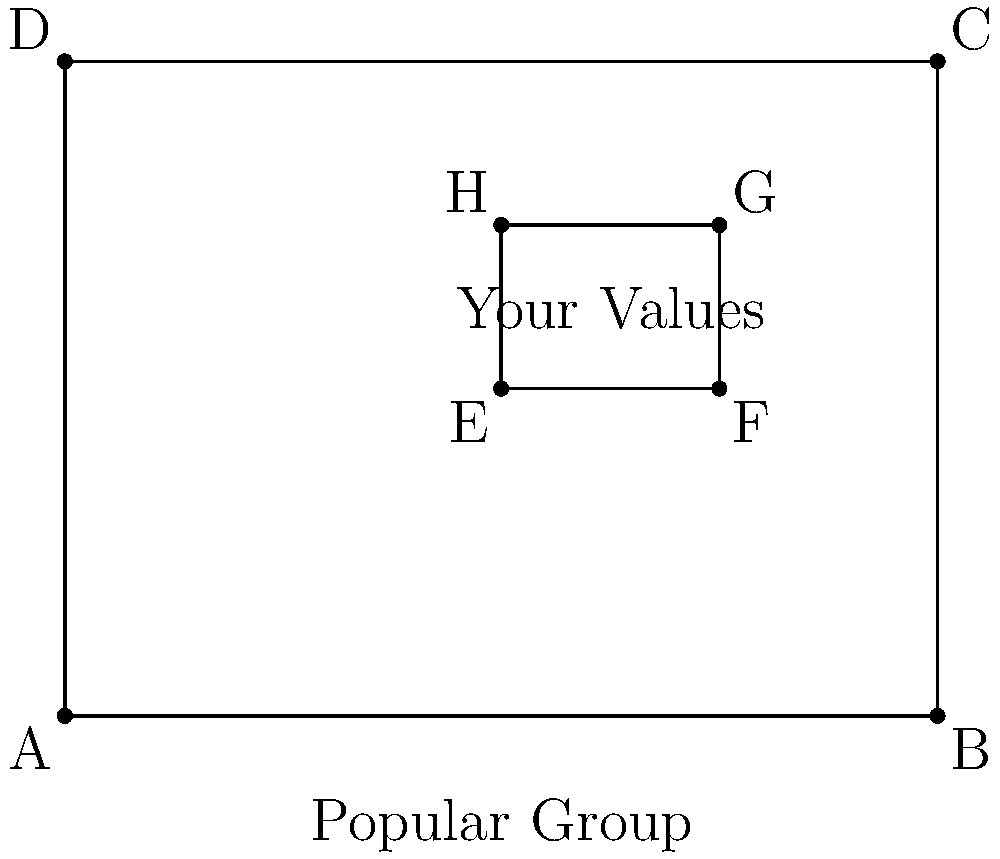In the diagram, rectangle ABCD represents the "Popular Group" at your high school, while rectangle EFGH represents "Your Values". If EFGH is congruent to a rectangle that is 25% of ABCD's area, what fraction of your values align with the popular group's values? Express your answer as a fraction in its simplest form. Let's approach this step-by-step:

1) First, we need to understand what it means for EFGH to be congruent to a rectangle that is 25% of ABCD's area.
   - This means that the area of EFGH is equal to 25% of ABCD's area.

2) Now, let's consider the area of rectangle ABCD:
   - Area of ABCD = length × width = 4 × 3 = 12 square units

3) The area of EFGH is 25% of ABCD's area:
   - Area of EFGH = 25% of 12 = 0.25 × 12 = 3 square units

4) Now, we need to find what fraction of ABCD is covered by EFGH:
   - Fraction = Area of EFGH ÷ Area of ABCD
   - Fraction = 3 ÷ 12 = 1/4

5) This fraction represents the overlap between "Your Values" and the "Popular Group's Values".

Therefore, 1/4 of your values align with the popular group's values.
Answer: 1/4 